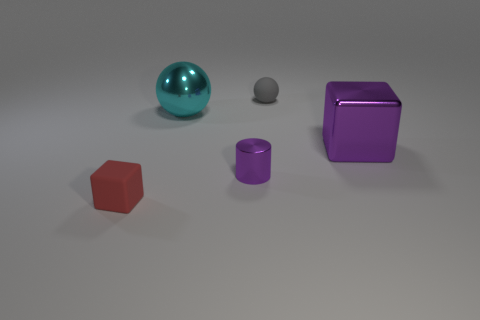What does the lighting in the image suggest about the environment where these objects are placed? The soft, diffuse lighting and the absence of shadows hint that these objects could be in an evenly lit indoor space, perhaps a studio setup where the intent is to focus solely on the objects without any external distraction. 